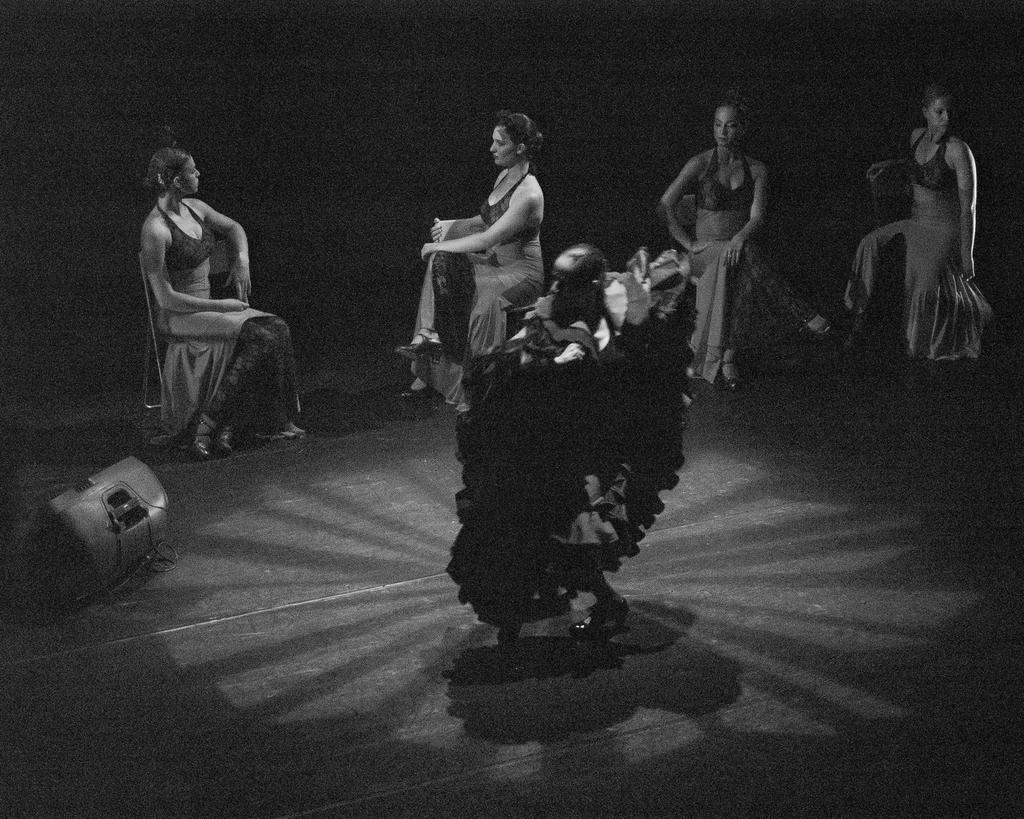How many people are in the image? There is a group of people in the image. What are some of the people in the image doing? Some people are seated on chairs. What can be seen on the left side of the image? There is a black and white photography on the left side of the image. What type of bomb is being used by the people in the image? There is no bomb present in the image; it features a group of people and a black and white photography. What type of plough is visible in the image? There is no plough present in the image. 